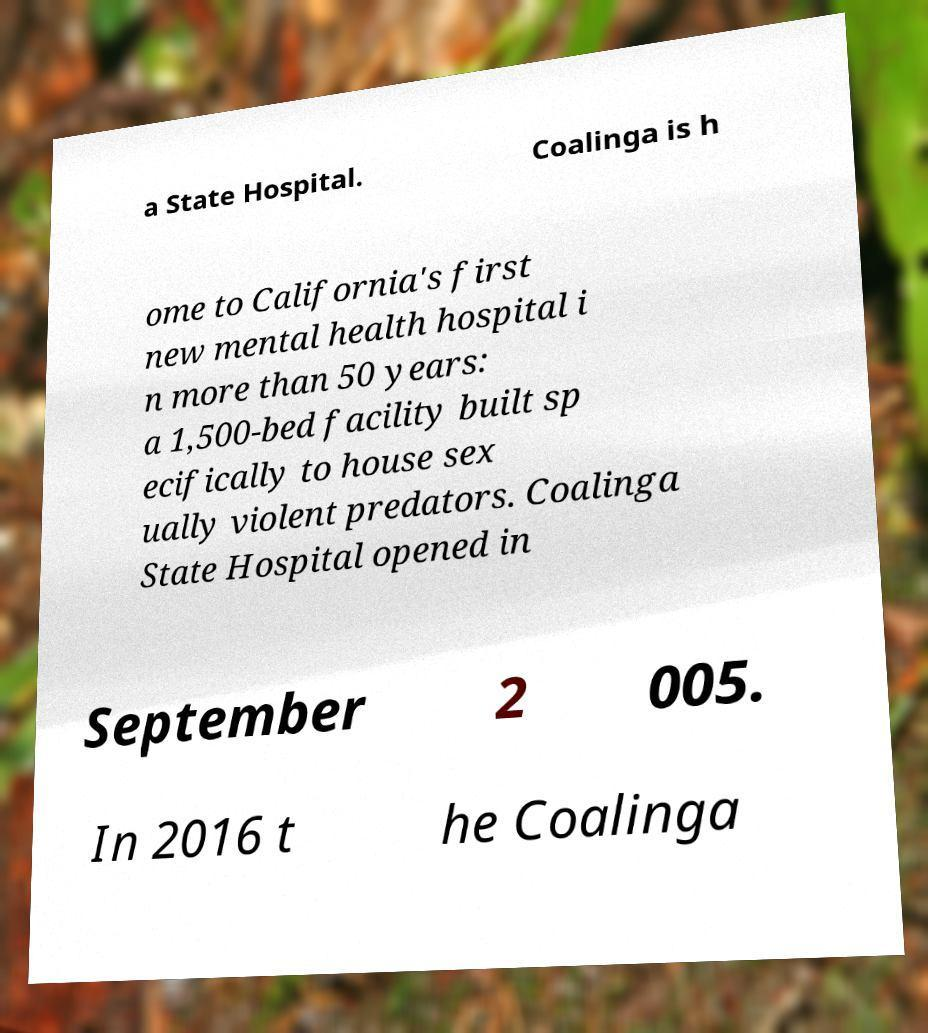There's text embedded in this image that I need extracted. Can you transcribe it verbatim? a State Hospital. Coalinga is h ome to California's first new mental health hospital i n more than 50 years: a 1,500-bed facility built sp ecifically to house sex ually violent predators. Coalinga State Hospital opened in September 2 005. In 2016 t he Coalinga 